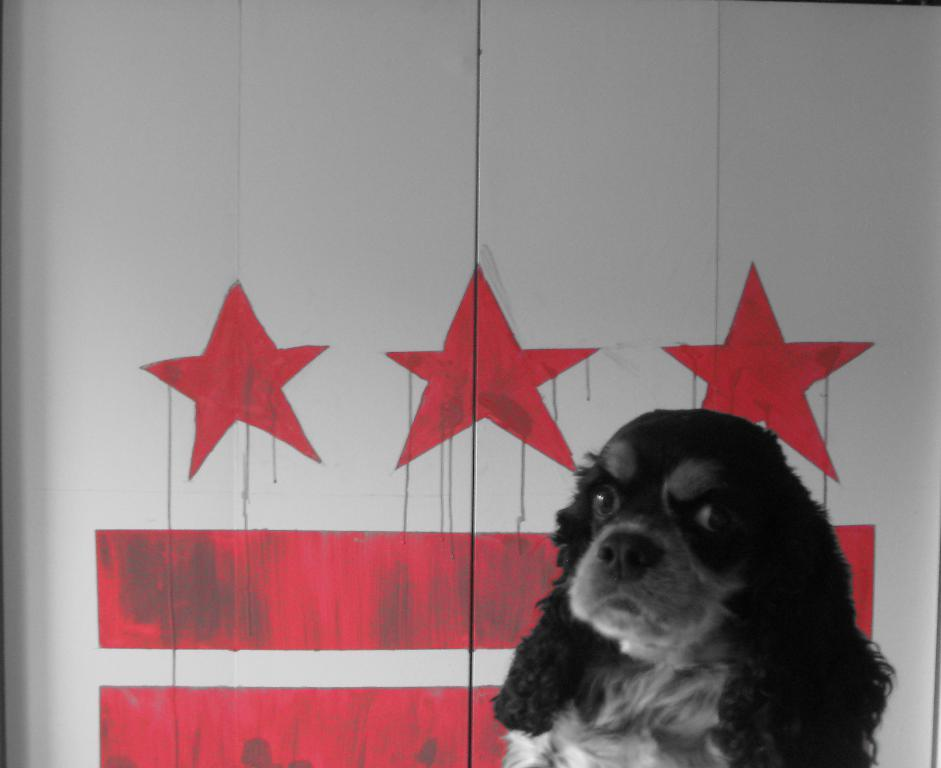What type of animal is present in the image? There is a dog in the image. What can be seen behind the dog? There are paintings on an object behind the dog. What type of stick is the dog holding in the image? There is no stick present in the image; the dog is not holding anything. 